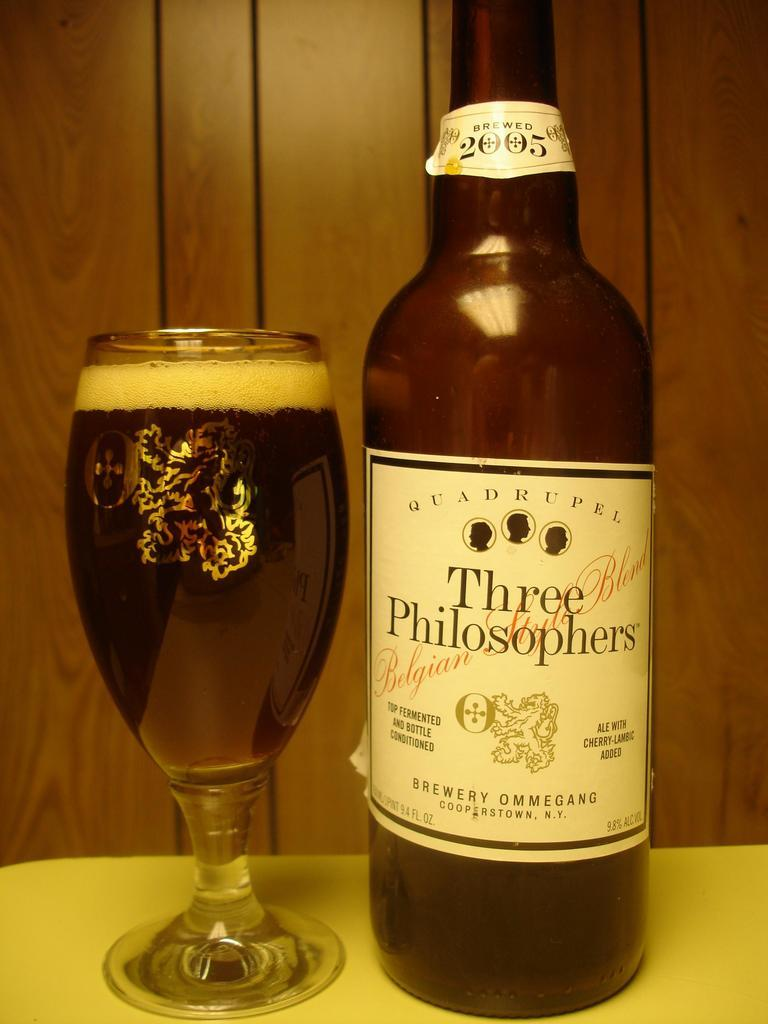<image>
Present a compact description of the photo's key features. A bottle of Three Philosophers next to a full glass. 